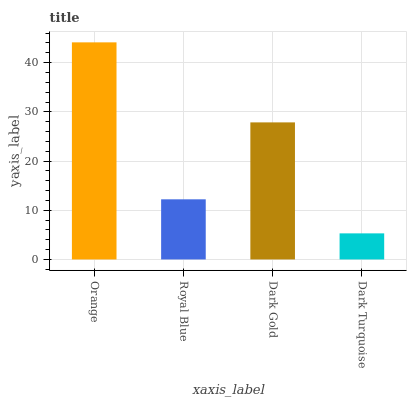Is Dark Turquoise the minimum?
Answer yes or no. Yes. Is Orange the maximum?
Answer yes or no. Yes. Is Royal Blue the minimum?
Answer yes or no. No. Is Royal Blue the maximum?
Answer yes or no. No. Is Orange greater than Royal Blue?
Answer yes or no. Yes. Is Royal Blue less than Orange?
Answer yes or no. Yes. Is Royal Blue greater than Orange?
Answer yes or no. No. Is Orange less than Royal Blue?
Answer yes or no. No. Is Dark Gold the high median?
Answer yes or no. Yes. Is Royal Blue the low median?
Answer yes or no. Yes. Is Orange the high median?
Answer yes or no. No. Is Orange the low median?
Answer yes or no. No. 